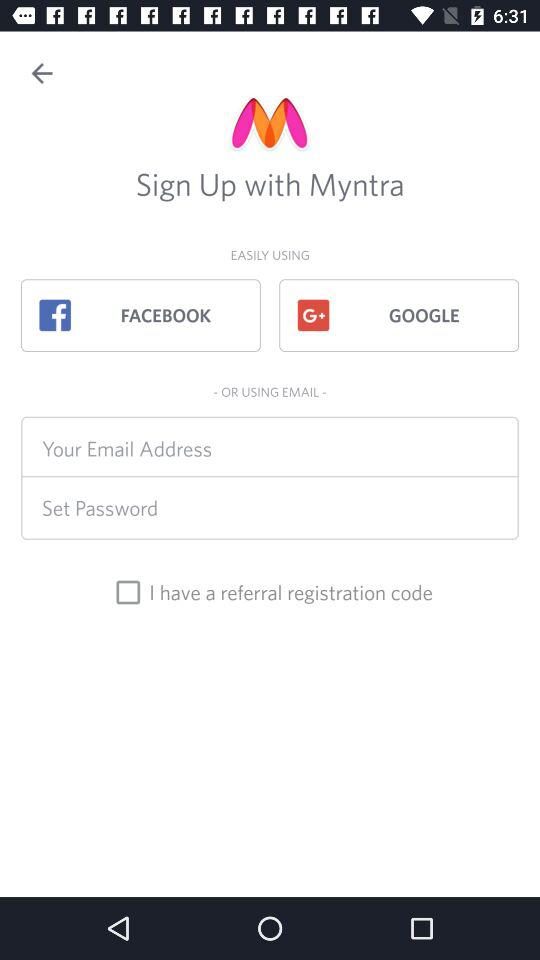What are the options to sign up? The options to sign up are "FACEBOOK", "GOOGLE" and "EMAIL". 